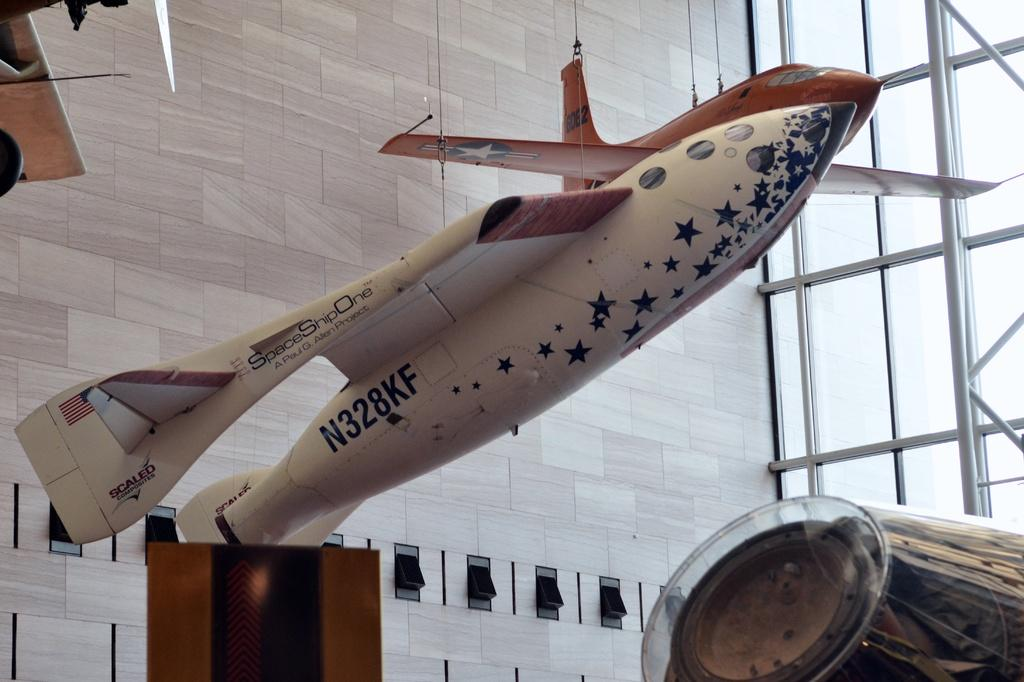<image>
Relay a brief, clear account of the picture shown. Space Ship One plane on display with the plate N328KF. 